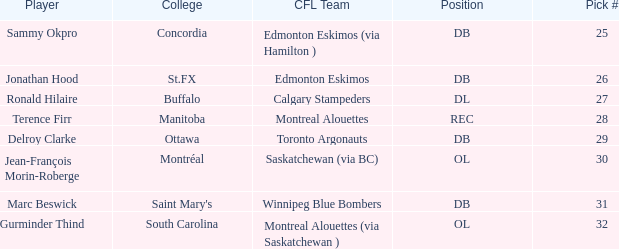Which College has a Pick # larger than 30, and a Position of ol? South Carolina. 